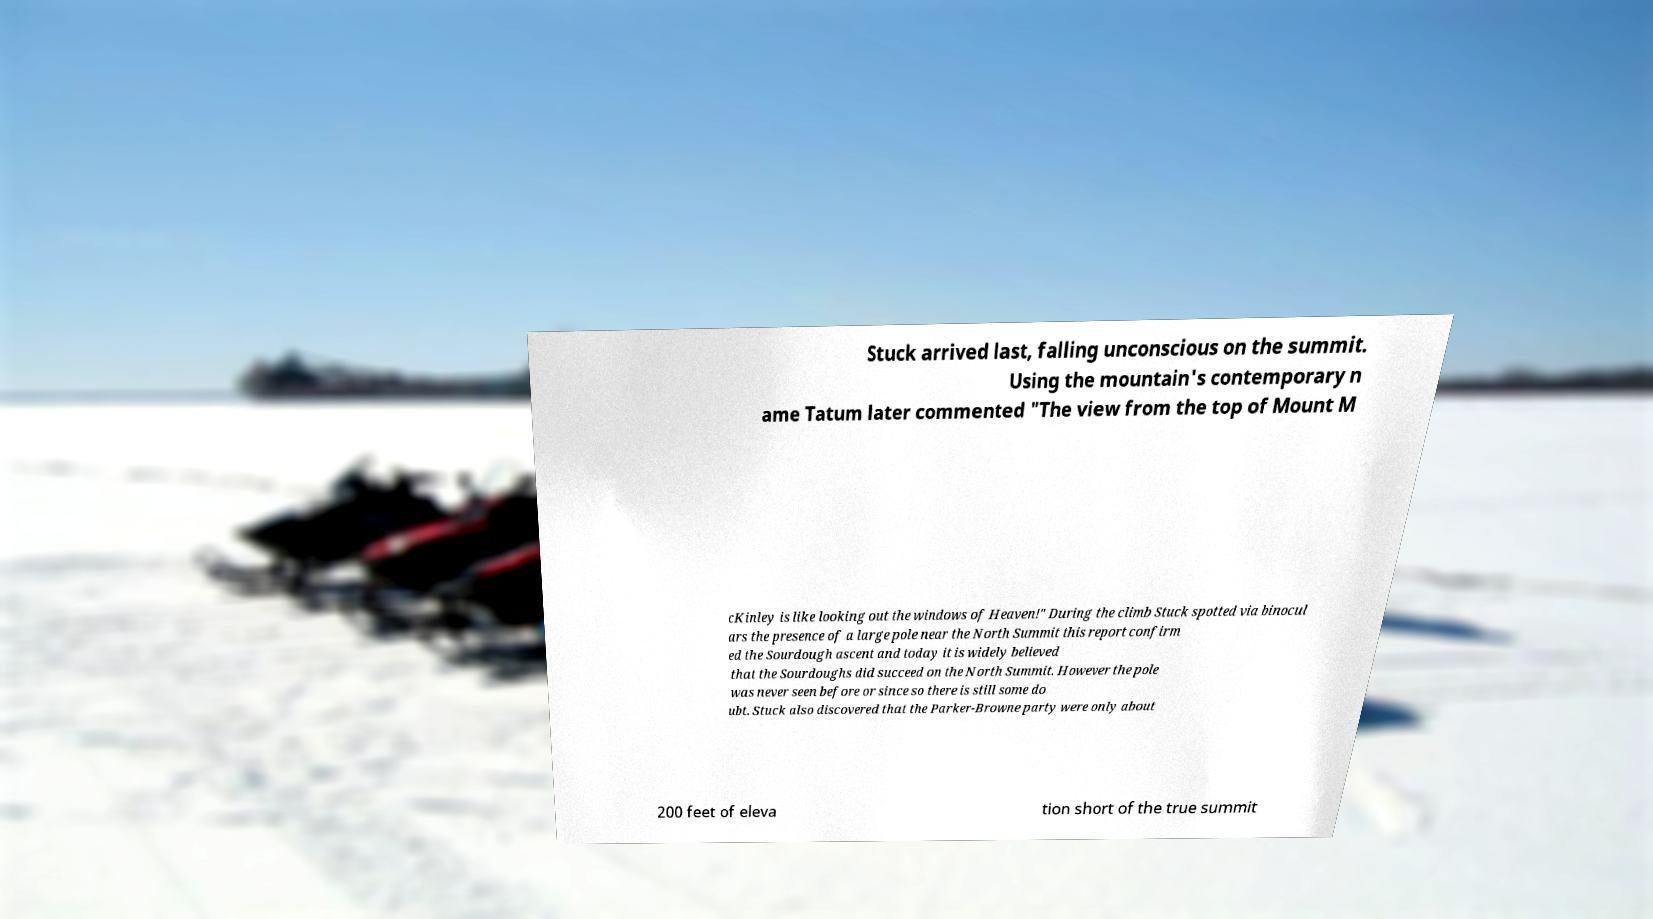Please identify and transcribe the text found in this image. Stuck arrived last, falling unconscious on the summit. Using the mountain's contemporary n ame Tatum later commented "The view from the top of Mount M cKinley is like looking out the windows of Heaven!" During the climb Stuck spotted via binocul ars the presence of a large pole near the North Summit this report confirm ed the Sourdough ascent and today it is widely believed that the Sourdoughs did succeed on the North Summit. However the pole was never seen before or since so there is still some do ubt. Stuck also discovered that the Parker-Browne party were only about 200 feet of eleva tion short of the true summit 